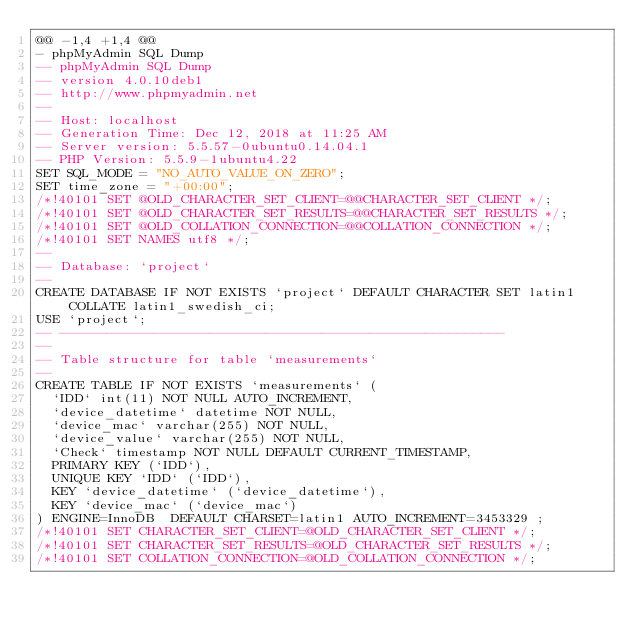<code> <loc_0><loc_0><loc_500><loc_500><_SQL_>@@ -1,4 +1,4 @@
- phpMyAdmin SQL Dump
-- phpMyAdmin SQL Dump
-- version 4.0.10deb1
-- http://www.phpmyadmin.net
--
-- Host: localhost
-- Generation Time: Dec 12, 2018 at 11:25 AM
-- Server version: 5.5.57-0ubuntu0.14.04.1
-- PHP Version: 5.5.9-1ubuntu4.22
SET SQL_MODE = "NO_AUTO_VALUE_ON_ZERO";
SET time_zone = "+00:00";
/*!40101 SET @OLD_CHARACTER_SET_CLIENT=@@CHARACTER_SET_CLIENT */;
/*!40101 SET @OLD_CHARACTER_SET_RESULTS=@@CHARACTER_SET_RESULTS */;
/*!40101 SET @OLD_COLLATION_CONNECTION=@@COLLATION_CONNECTION */;
/*!40101 SET NAMES utf8 */;
--
-- Database: `project`
--
CREATE DATABASE IF NOT EXISTS `project` DEFAULT CHARACTER SET latin1 COLLATE latin1_swedish_ci;
USE `project`;
-- --------------------------------------------------------
--
-- Table structure for table `measurements`
--
CREATE TABLE IF NOT EXISTS `measurements` (
  `IDD` int(11) NOT NULL AUTO_INCREMENT,
  `device_datetime` datetime NOT NULL,
  `device_mac` varchar(255) NOT NULL,
  `device_value` varchar(255) NOT NULL,
  `Check` timestamp NOT NULL DEFAULT CURRENT_TIMESTAMP,
  PRIMARY KEY (`IDD`),
  UNIQUE KEY `IDD` (`IDD`),
  KEY `device_datetime` (`device_datetime`),
  KEY `device_mac` (`device_mac`)
) ENGINE=InnoDB  DEFAULT CHARSET=latin1 AUTO_INCREMENT=3453329 ;
/*!40101 SET CHARACTER_SET_CLIENT=@OLD_CHARACTER_SET_CLIENT */;
/*!40101 SET CHARACTER_SET_RESULTS=@OLD_CHARACTER_SET_RESULTS */;
/*!40101 SET COLLATION_CONNECTION=@OLD_COLLATION_CONNECTION */;
</code> 